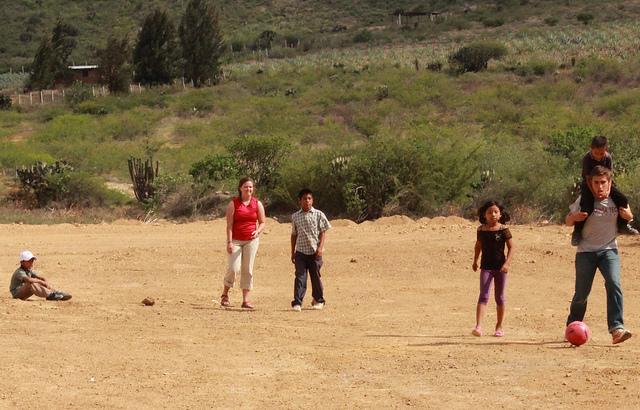Is the game being played in a desert area?
Give a very brief answer. Yes. How many people are over the age of 18?
Answer briefly. 2. Are all the people playing soccer?
Quick response, please. No. What is on the man's back?
Be succinct. Child. Where is the soccer ball?
Give a very brief answer. On ground. 